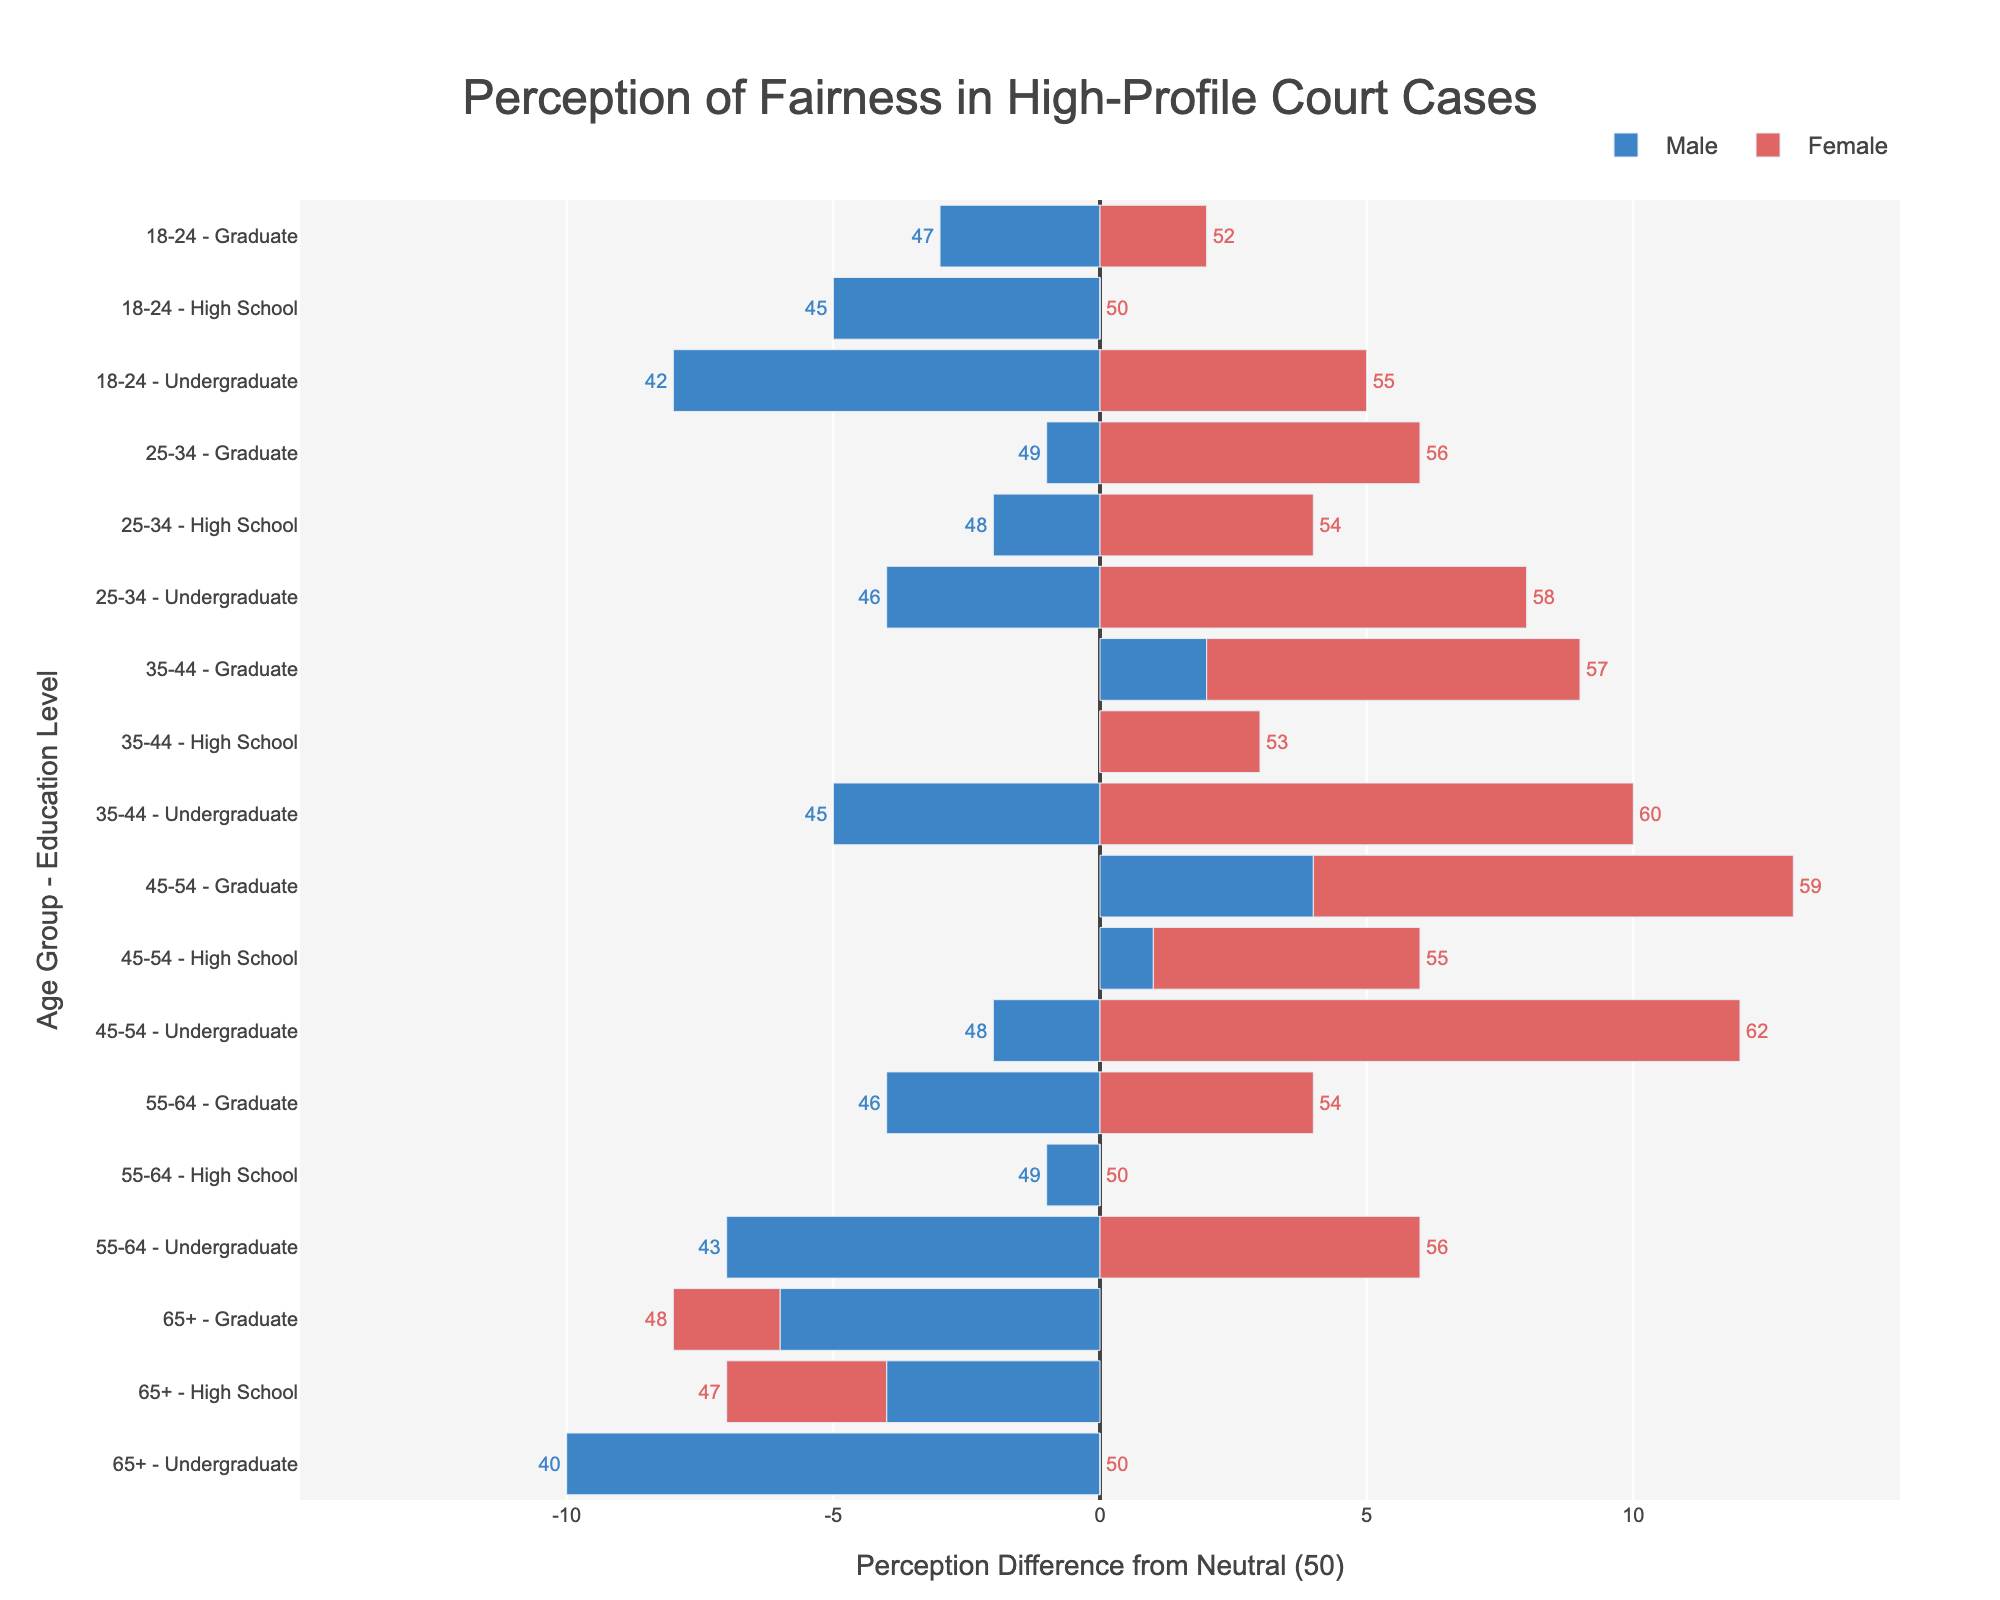1. Which gender has a higher average perception of fairness in the "Undergraduate" education level across all age groups? To calculate the average perception of fairness, sum the perception values for each gender and then divide by the number of data points. For "Undergraduate" level, males have perceptions: 42, 46, 45, 48, 43, 40, summing to 264, and females have perceptions: 55,58,60,62,56,50, summing to 341. There are 6 data points for both, so the averages are 264/6 = 44 for males and 341/6 = 56.83 for females.
Answer: Female 2. What is the perception difference between males and females in the "Graduate" level for the 45-54 age group? Identify the perception values for males and females in the "Graduate" level for 45-54 age group. Males have a perception of 54, and females have a perception of 59. The difference is 59 - 54 = 5.
Answer: 5 3. Which age group shows the least perception of fairness among males with "Graduate" education? Identify the perception values for males with "Graduate" education level across all age groups. These values are 47, 49, 52, 54, 46, 44. The smallest value is 44 for the 65+ age group.
Answer: 65+ 4. How does the perception of fairness compare between males and females in the high school education level for the 18-24 age group? Look at the perception values for males and females in the High School education level for the 18-24 age group. Males have a perception of 45, and females have a perception of 50. Therefore, females perceive fairness higher by 50 - 45 = 5 points.
Answer: Females perceive higher 5. What is the total sum of perception points for females in the 35-44 age group? Identify the perception values for females in the 35-44 age group. The values are 53, 60, 57. Summing these values, 53 + 60 + 57 = 170.
Answer: 170 6. Which of the two groups has a higher perception of fairness: 25-34 age group with undergraduate education or 55-64 age group with high school education? Identify the perception values for the 25-34 age group with undergraduate education: males 46, females 58 (average = 52) and for the 55-64 age group with high school education: males 49, females 50 (average = 49.5). The average perception is 52 for the first group and 49.5 for the second group. Hence, the 25-34 age group with undergraduate education has a higher perception.
Answer: 25-34 age group with undergraduate education 7. Which educational level in the 45-54 age group has the highest perception of fairness among females? Identify the perception values for females in the various education levels within the 45-54 age group. The values are: High School 55, Undergraduate 62, Graduate 59. The highest perception value is 62 for Undergraduate.
Answer: Undergraduate 8. What is the median perception of fairness among all groups with "High School" education, irrespective of gender? List all the perception values for the "High School" education level: 45, 50, 48, 54, 50, 53, 51, 55, 49, 50, 46, 47. Sorting these values gives: 45, 46, 47, 48, 49, 50, 50, 51, 53, 54, 55. The median is the average of the 6th and 7th values: (50 + 50) / 2 = 50.
Answer: 50 